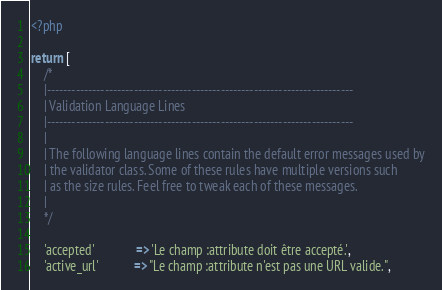Convert code to text. <code><loc_0><loc_0><loc_500><loc_500><_PHP_><?php

return [
    /*
    |--------------------------------------------------------------------------
    | Validation Language Lines
    |--------------------------------------------------------------------------
    |
    | The following language lines contain the default error messages used by
    | the validator class. Some of these rules have multiple versions such
    | as the size rules. Feel free to tweak each of these messages.
    |
    */

    'accepted'             => 'Le champ :attribute doit être accepté.',
    'active_url'           => "Le champ :attribute n'est pas une URL valide.",</code> 